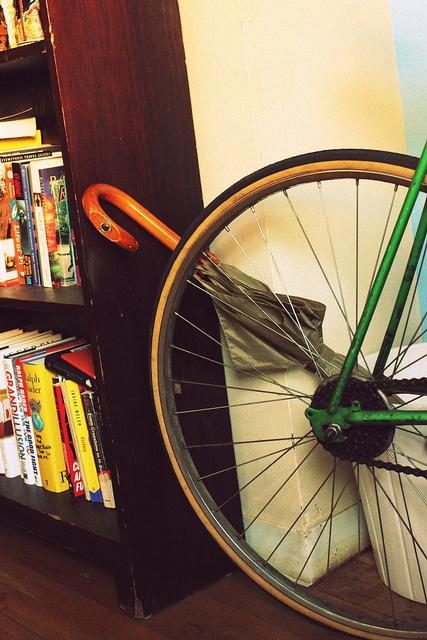How many spokes are on the bike wheel?
Be succinct. 35. How many books in the case?
Give a very brief answer. Many. What is sticking out the trash can?
Concise answer only. Umbrella. 